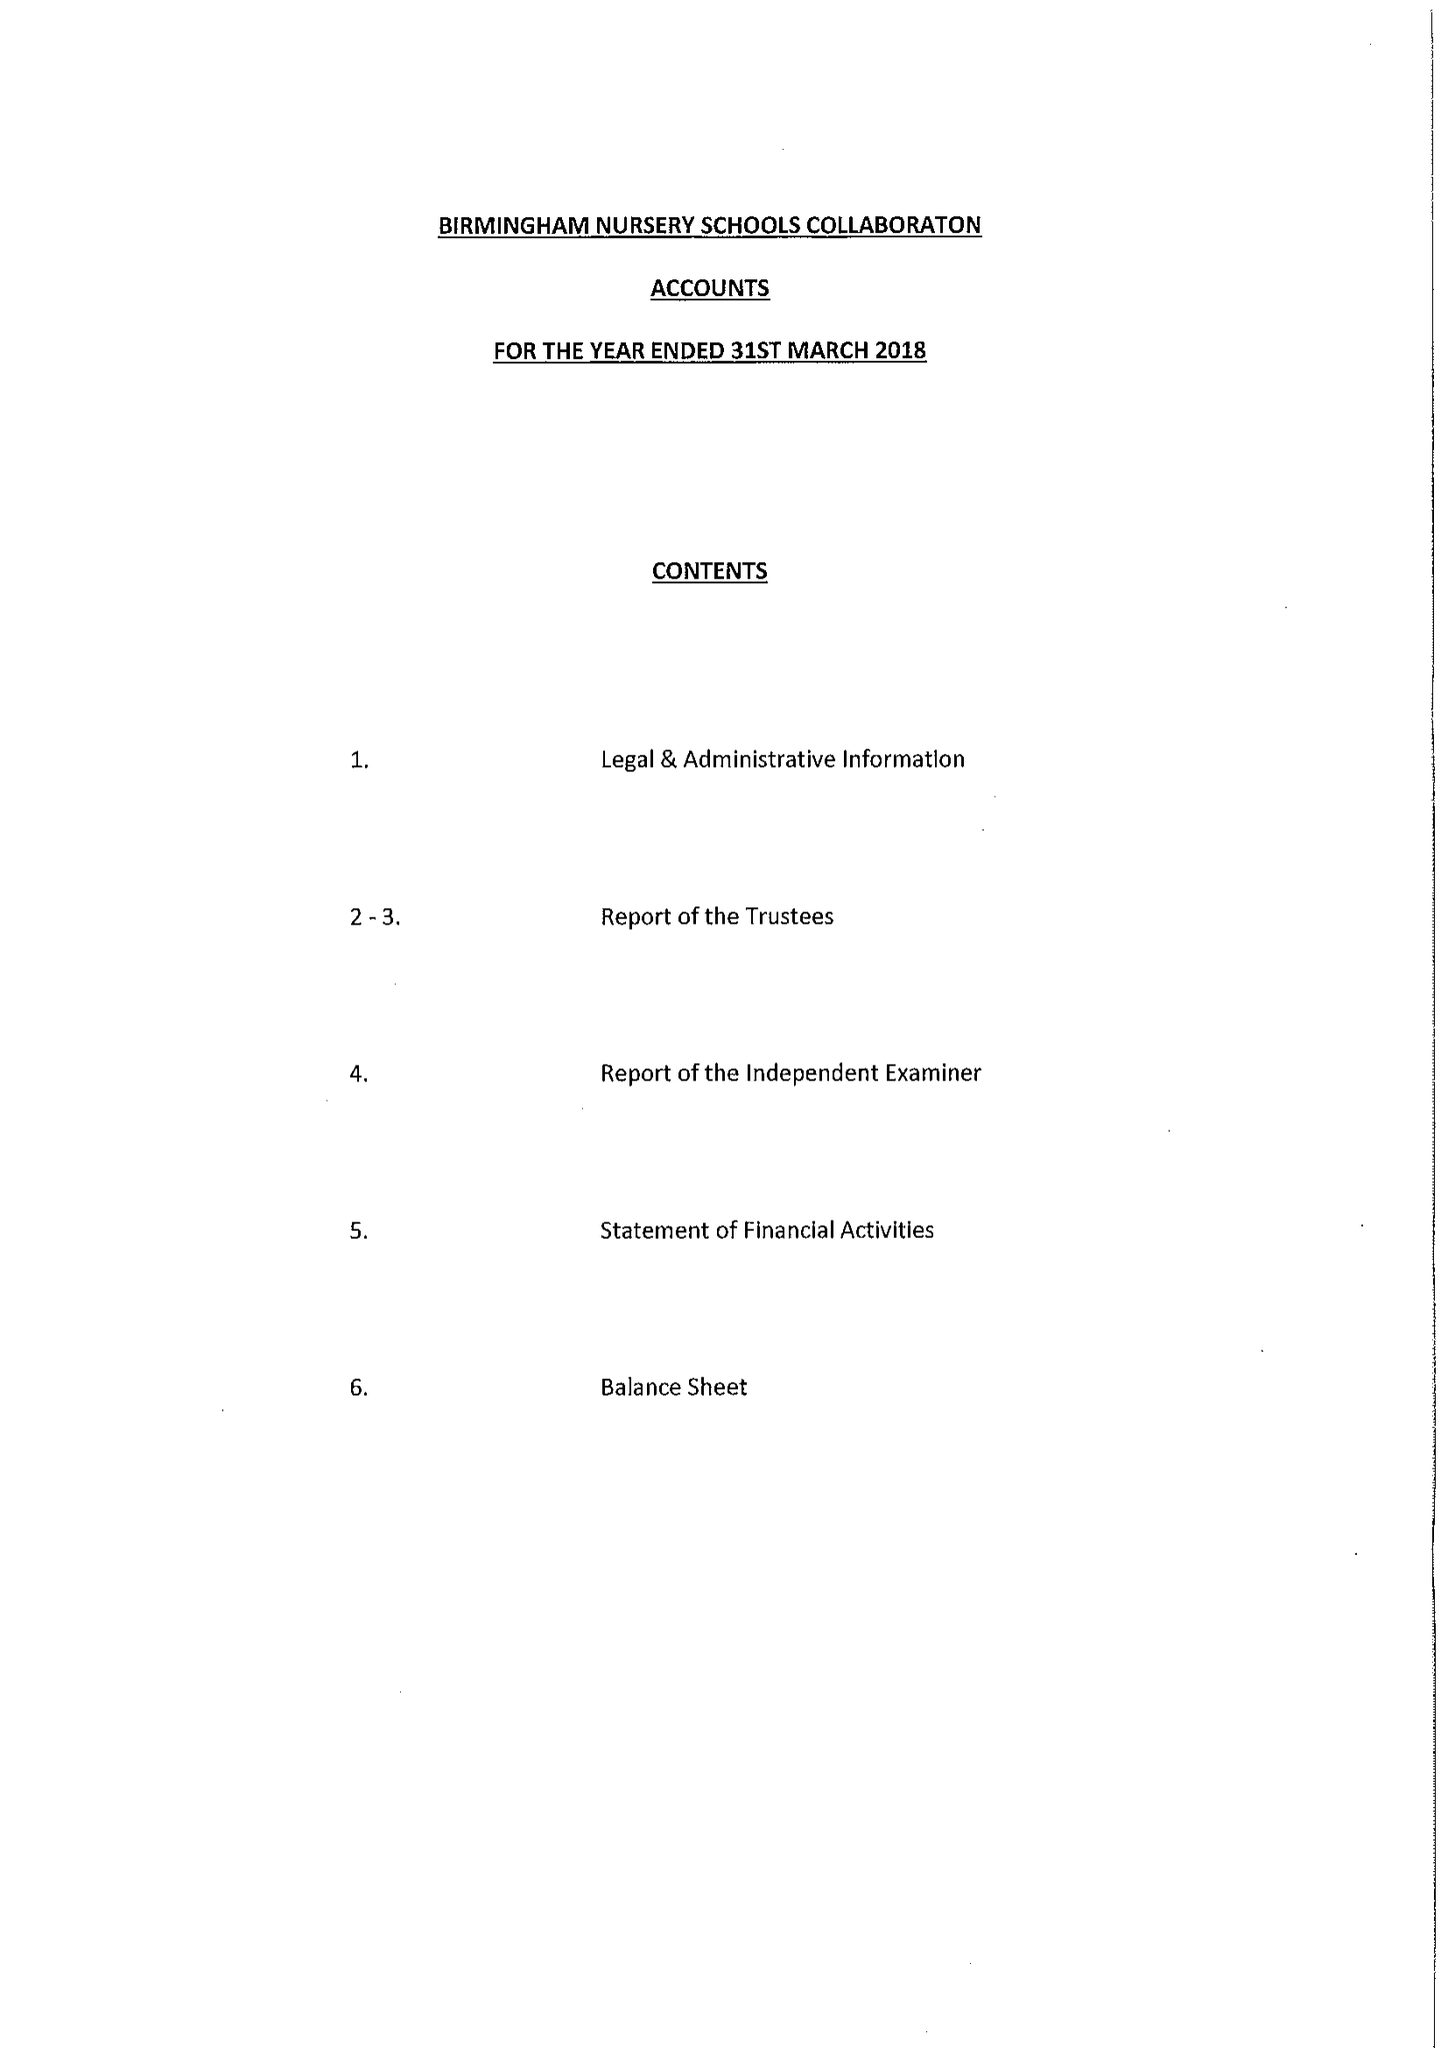What is the value for the report_date?
Answer the question using a single word or phrase. 2018-03-31 